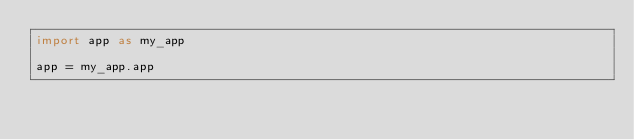<code> <loc_0><loc_0><loc_500><loc_500><_Python_>import app as my_app

app = my_app.app</code> 